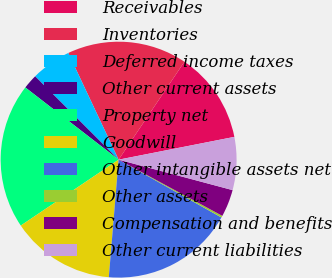Convert chart. <chart><loc_0><loc_0><loc_500><loc_500><pie_chart><fcel>Receivables<fcel>Inventories<fcel>Deferred income taxes<fcel>Other current assets<fcel>Property net<fcel>Goodwill<fcel>Other intangible assets net<fcel>Other assets<fcel>Compensation and benefits<fcel>Other current liabilities<nl><fcel>12.49%<fcel>16.43%<fcel>5.5%<fcel>2.0%<fcel>19.92%<fcel>14.24%<fcel>18.17%<fcel>0.25%<fcel>3.75%<fcel>7.25%<nl></chart> 